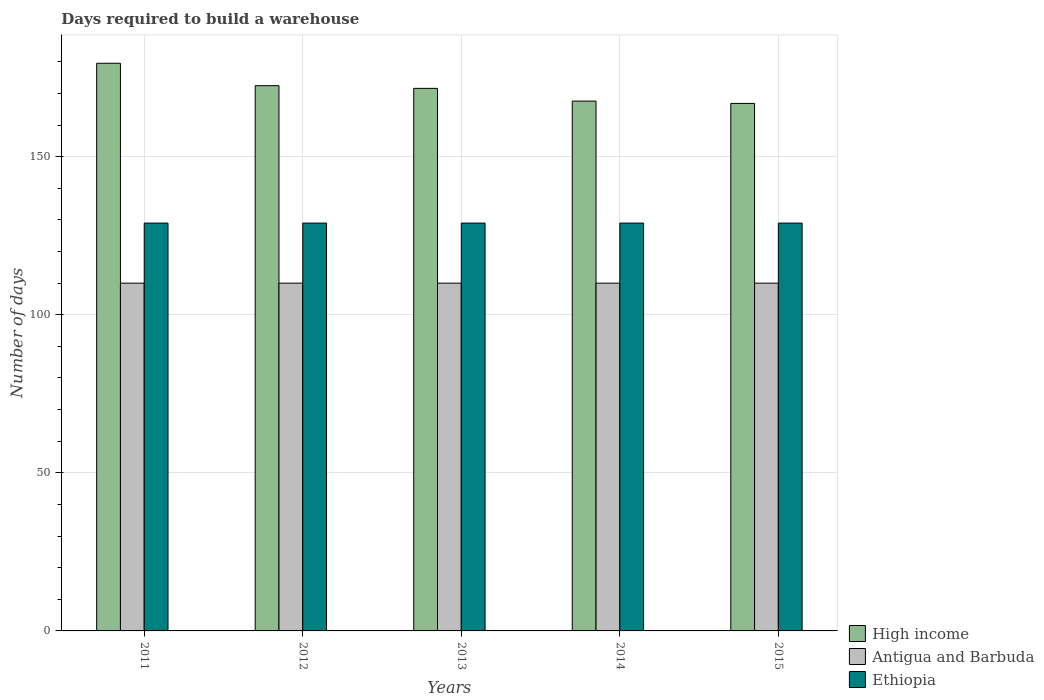How many different coloured bars are there?
Provide a succinct answer. 3. How many groups of bars are there?
Your response must be concise. 5. Are the number of bars per tick equal to the number of legend labels?
Provide a succinct answer. Yes. Are the number of bars on each tick of the X-axis equal?
Keep it short and to the point. Yes. What is the label of the 5th group of bars from the left?
Your answer should be very brief. 2015. What is the days required to build a warehouse in in Ethiopia in 2012?
Give a very brief answer. 129. Across all years, what is the maximum days required to build a warehouse in in High income?
Provide a short and direct response. 179.55. Across all years, what is the minimum days required to build a warehouse in in Ethiopia?
Keep it short and to the point. 129. What is the total days required to build a warehouse in in High income in the graph?
Ensure brevity in your answer.  858.07. What is the difference between the days required to build a warehouse in in High income in 2012 and that in 2015?
Provide a succinct answer. 5.61. What is the difference between the days required to build a warehouse in in High income in 2014 and the days required to build a warehouse in in Antigua and Barbuda in 2012?
Provide a succinct answer. 57.59. What is the average days required to build a warehouse in in Antigua and Barbuda per year?
Your answer should be compact. 110. In the year 2014, what is the difference between the days required to build a warehouse in in High income and days required to build a warehouse in in Ethiopia?
Your answer should be very brief. 38.59. In how many years, is the days required to build a warehouse in in Ethiopia greater than 150 days?
Keep it short and to the point. 0. What is the ratio of the days required to build a warehouse in in High income in 2013 to that in 2015?
Offer a terse response. 1.03. Is the days required to build a warehouse in in Ethiopia in 2013 less than that in 2015?
Your answer should be compact. No. Is the difference between the days required to build a warehouse in in High income in 2012 and 2014 greater than the difference between the days required to build a warehouse in in Ethiopia in 2012 and 2014?
Provide a short and direct response. Yes. What is the difference between the highest and the second highest days required to build a warehouse in in Antigua and Barbuda?
Ensure brevity in your answer.  0. What is the difference between the highest and the lowest days required to build a warehouse in in High income?
Make the answer very short. 12.7. In how many years, is the days required to build a warehouse in in Antigua and Barbuda greater than the average days required to build a warehouse in in Antigua and Barbuda taken over all years?
Offer a very short reply. 0. What does the 3rd bar from the left in 2013 represents?
Keep it short and to the point. Ethiopia. Is it the case that in every year, the sum of the days required to build a warehouse in in Ethiopia and days required to build a warehouse in in High income is greater than the days required to build a warehouse in in Antigua and Barbuda?
Your answer should be very brief. Yes. How many bars are there?
Give a very brief answer. 15. How many years are there in the graph?
Your response must be concise. 5. What is the difference between two consecutive major ticks on the Y-axis?
Offer a very short reply. 50. Does the graph contain any zero values?
Give a very brief answer. No. Where does the legend appear in the graph?
Your response must be concise. Bottom right. What is the title of the graph?
Offer a very short reply. Days required to build a warehouse. Does "Isle of Man" appear as one of the legend labels in the graph?
Offer a very short reply. No. What is the label or title of the Y-axis?
Your response must be concise. Number of days. What is the Number of days in High income in 2011?
Keep it short and to the point. 179.55. What is the Number of days of Antigua and Barbuda in 2011?
Your answer should be very brief. 110. What is the Number of days of Ethiopia in 2011?
Make the answer very short. 129. What is the Number of days of High income in 2012?
Provide a short and direct response. 172.46. What is the Number of days in Antigua and Barbuda in 2012?
Ensure brevity in your answer.  110. What is the Number of days of Ethiopia in 2012?
Offer a very short reply. 129. What is the Number of days in High income in 2013?
Ensure brevity in your answer.  171.61. What is the Number of days of Antigua and Barbuda in 2013?
Provide a short and direct response. 110. What is the Number of days in Ethiopia in 2013?
Provide a short and direct response. 129. What is the Number of days of High income in 2014?
Offer a terse response. 167.59. What is the Number of days in Antigua and Barbuda in 2014?
Your response must be concise. 110. What is the Number of days in Ethiopia in 2014?
Offer a very short reply. 129. What is the Number of days of High income in 2015?
Your answer should be very brief. 166.85. What is the Number of days of Antigua and Barbuda in 2015?
Offer a terse response. 110. What is the Number of days of Ethiopia in 2015?
Offer a terse response. 129. Across all years, what is the maximum Number of days of High income?
Ensure brevity in your answer.  179.55. Across all years, what is the maximum Number of days of Antigua and Barbuda?
Keep it short and to the point. 110. Across all years, what is the maximum Number of days in Ethiopia?
Offer a very short reply. 129. Across all years, what is the minimum Number of days in High income?
Provide a short and direct response. 166.85. Across all years, what is the minimum Number of days of Antigua and Barbuda?
Provide a succinct answer. 110. Across all years, what is the minimum Number of days in Ethiopia?
Make the answer very short. 129. What is the total Number of days in High income in the graph?
Your answer should be very brief. 858.07. What is the total Number of days in Antigua and Barbuda in the graph?
Your answer should be very brief. 550. What is the total Number of days of Ethiopia in the graph?
Make the answer very short. 645. What is the difference between the Number of days of High income in 2011 and that in 2012?
Ensure brevity in your answer.  7.09. What is the difference between the Number of days of High income in 2011 and that in 2013?
Your answer should be very brief. 7.94. What is the difference between the Number of days of Antigua and Barbuda in 2011 and that in 2013?
Give a very brief answer. 0. What is the difference between the Number of days in High income in 2011 and that in 2014?
Give a very brief answer. 11.97. What is the difference between the Number of days in Ethiopia in 2011 and that in 2014?
Offer a terse response. 0. What is the difference between the Number of days of High income in 2011 and that in 2015?
Your response must be concise. 12.7. What is the difference between the Number of days in Antigua and Barbuda in 2011 and that in 2015?
Offer a terse response. 0. What is the difference between the Number of days of Ethiopia in 2011 and that in 2015?
Offer a very short reply. 0. What is the difference between the Number of days in High income in 2012 and that in 2013?
Provide a succinct answer. 0.85. What is the difference between the Number of days of Ethiopia in 2012 and that in 2013?
Offer a very short reply. 0. What is the difference between the Number of days of High income in 2012 and that in 2014?
Your response must be concise. 4.88. What is the difference between the Number of days of Antigua and Barbuda in 2012 and that in 2014?
Make the answer very short. 0. What is the difference between the Number of days in Ethiopia in 2012 and that in 2014?
Your answer should be compact. 0. What is the difference between the Number of days of High income in 2012 and that in 2015?
Your response must be concise. 5.61. What is the difference between the Number of days of High income in 2013 and that in 2014?
Provide a short and direct response. 4.03. What is the difference between the Number of days of High income in 2013 and that in 2015?
Provide a short and direct response. 4.76. What is the difference between the Number of days in Antigua and Barbuda in 2013 and that in 2015?
Ensure brevity in your answer.  0. What is the difference between the Number of days of Ethiopia in 2013 and that in 2015?
Keep it short and to the point. 0. What is the difference between the Number of days in High income in 2014 and that in 2015?
Ensure brevity in your answer.  0.73. What is the difference between the Number of days of Antigua and Barbuda in 2014 and that in 2015?
Give a very brief answer. 0. What is the difference between the Number of days of Ethiopia in 2014 and that in 2015?
Provide a short and direct response. 0. What is the difference between the Number of days of High income in 2011 and the Number of days of Antigua and Barbuda in 2012?
Your answer should be compact. 69.55. What is the difference between the Number of days in High income in 2011 and the Number of days in Ethiopia in 2012?
Your answer should be compact. 50.55. What is the difference between the Number of days in Antigua and Barbuda in 2011 and the Number of days in Ethiopia in 2012?
Keep it short and to the point. -19. What is the difference between the Number of days in High income in 2011 and the Number of days in Antigua and Barbuda in 2013?
Provide a short and direct response. 69.55. What is the difference between the Number of days of High income in 2011 and the Number of days of Ethiopia in 2013?
Your response must be concise. 50.55. What is the difference between the Number of days of High income in 2011 and the Number of days of Antigua and Barbuda in 2014?
Your response must be concise. 69.55. What is the difference between the Number of days of High income in 2011 and the Number of days of Ethiopia in 2014?
Offer a terse response. 50.55. What is the difference between the Number of days in High income in 2011 and the Number of days in Antigua and Barbuda in 2015?
Your answer should be compact. 69.55. What is the difference between the Number of days in High income in 2011 and the Number of days in Ethiopia in 2015?
Ensure brevity in your answer.  50.55. What is the difference between the Number of days of Antigua and Barbuda in 2011 and the Number of days of Ethiopia in 2015?
Your answer should be very brief. -19. What is the difference between the Number of days in High income in 2012 and the Number of days in Antigua and Barbuda in 2013?
Ensure brevity in your answer.  62.46. What is the difference between the Number of days of High income in 2012 and the Number of days of Ethiopia in 2013?
Keep it short and to the point. 43.46. What is the difference between the Number of days of High income in 2012 and the Number of days of Antigua and Barbuda in 2014?
Offer a terse response. 62.46. What is the difference between the Number of days of High income in 2012 and the Number of days of Ethiopia in 2014?
Offer a terse response. 43.46. What is the difference between the Number of days of High income in 2012 and the Number of days of Antigua and Barbuda in 2015?
Offer a very short reply. 62.46. What is the difference between the Number of days of High income in 2012 and the Number of days of Ethiopia in 2015?
Your response must be concise. 43.46. What is the difference between the Number of days in High income in 2013 and the Number of days in Antigua and Barbuda in 2014?
Provide a succinct answer. 61.61. What is the difference between the Number of days of High income in 2013 and the Number of days of Ethiopia in 2014?
Your answer should be compact. 42.61. What is the difference between the Number of days in High income in 2013 and the Number of days in Antigua and Barbuda in 2015?
Provide a succinct answer. 61.61. What is the difference between the Number of days in High income in 2013 and the Number of days in Ethiopia in 2015?
Give a very brief answer. 42.61. What is the difference between the Number of days of Antigua and Barbuda in 2013 and the Number of days of Ethiopia in 2015?
Offer a terse response. -19. What is the difference between the Number of days in High income in 2014 and the Number of days in Antigua and Barbuda in 2015?
Keep it short and to the point. 57.59. What is the difference between the Number of days of High income in 2014 and the Number of days of Ethiopia in 2015?
Your answer should be compact. 38.59. What is the difference between the Number of days in Antigua and Barbuda in 2014 and the Number of days in Ethiopia in 2015?
Your answer should be very brief. -19. What is the average Number of days of High income per year?
Your answer should be very brief. 171.61. What is the average Number of days of Antigua and Barbuda per year?
Keep it short and to the point. 110. What is the average Number of days in Ethiopia per year?
Give a very brief answer. 129. In the year 2011, what is the difference between the Number of days of High income and Number of days of Antigua and Barbuda?
Keep it short and to the point. 69.55. In the year 2011, what is the difference between the Number of days in High income and Number of days in Ethiopia?
Provide a short and direct response. 50.55. In the year 2012, what is the difference between the Number of days in High income and Number of days in Antigua and Barbuda?
Offer a terse response. 62.46. In the year 2012, what is the difference between the Number of days in High income and Number of days in Ethiopia?
Your answer should be compact. 43.46. In the year 2012, what is the difference between the Number of days of Antigua and Barbuda and Number of days of Ethiopia?
Offer a terse response. -19. In the year 2013, what is the difference between the Number of days in High income and Number of days in Antigua and Barbuda?
Provide a short and direct response. 61.61. In the year 2013, what is the difference between the Number of days of High income and Number of days of Ethiopia?
Make the answer very short. 42.61. In the year 2014, what is the difference between the Number of days of High income and Number of days of Antigua and Barbuda?
Provide a succinct answer. 57.59. In the year 2014, what is the difference between the Number of days in High income and Number of days in Ethiopia?
Give a very brief answer. 38.59. In the year 2015, what is the difference between the Number of days of High income and Number of days of Antigua and Barbuda?
Your response must be concise. 56.85. In the year 2015, what is the difference between the Number of days in High income and Number of days in Ethiopia?
Keep it short and to the point. 37.85. What is the ratio of the Number of days of High income in 2011 to that in 2012?
Your answer should be compact. 1.04. What is the ratio of the Number of days in High income in 2011 to that in 2013?
Provide a succinct answer. 1.05. What is the ratio of the Number of days of Antigua and Barbuda in 2011 to that in 2013?
Keep it short and to the point. 1. What is the ratio of the Number of days in Ethiopia in 2011 to that in 2013?
Provide a short and direct response. 1. What is the ratio of the Number of days of High income in 2011 to that in 2014?
Your answer should be compact. 1.07. What is the ratio of the Number of days of High income in 2011 to that in 2015?
Provide a succinct answer. 1.08. What is the ratio of the Number of days in Antigua and Barbuda in 2011 to that in 2015?
Provide a short and direct response. 1. What is the ratio of the Number of days of Ethiopia in 2011 to that in 2015?
Ensure brevity in your answer.  1. What is the ratio of the Number of days in High income in 2012 to that in 2013?
Provide a succinct answer. 1. What is the ratio of the Number of days of Antigua and Barbuda in 2012 to that in 2013?
Offer a very short reply. 1. What is the ratio of the Number of days in Ethiopia in 2012 to that in 2013?
Make the answer very short. 1. What is the ratio of the Number of days of High income in 2012 to that in 2014?
Offer a terse response. 1.03. What is the ratio of the Number of days in Antigua and Barbuda in 2012 to that in 2014?
Give a very brief answer. 1. What is the ratio of the Number of days in Ethiopia in 2012 to that in 2014?
Provide a short and direct response. 1. What is the ratio of the Number of days of High income in 2012 to that in 2015?
Your response must be concise. 1.03. What is the ratio of the Number of days in Antigua and Barbuda in 2012 to that in 2015?
Give a very brief answer. 1. What is the ratio of the Number of days in Ethiopia in 2012 to that in 2015?
Make the answer very short. 1. What is the ratio of the Number of days in Antigua and Barbuda in 2013 to that in 2014?
Your answer should be compact. 1. What is the ratio of the Number of days of High income in 2013 to that in 2015?
Give a very brief answer. 1.03. What is the ratio of the Number of days in Antigua and Barbuda in 2013 to that in 2015?
Provide a short and direct response. 1. What is the ratio of the Number of days in Ethiopia in 2013 to that in 2015?
Give a very brief answer. 1. What is the ratio of the Number of days of High income in 2014 to that in 2015?
Provide a succinct answer. 1. What is the ratio of the Number of days in Antigua and Barbuda in 2014 to that in 2015?
Your answer should be compact. 1. What is the difference between the highest and the second highest Number of days of High income?
Offer a terse response. 7.09. What is the difference between the highest and the lowest Number of days in High income?
Your response must be concise. 12.7. What is the difference between the highest and the lowest Number of days in Antigua and Barbuda?
Your answer should be compact. 0. 